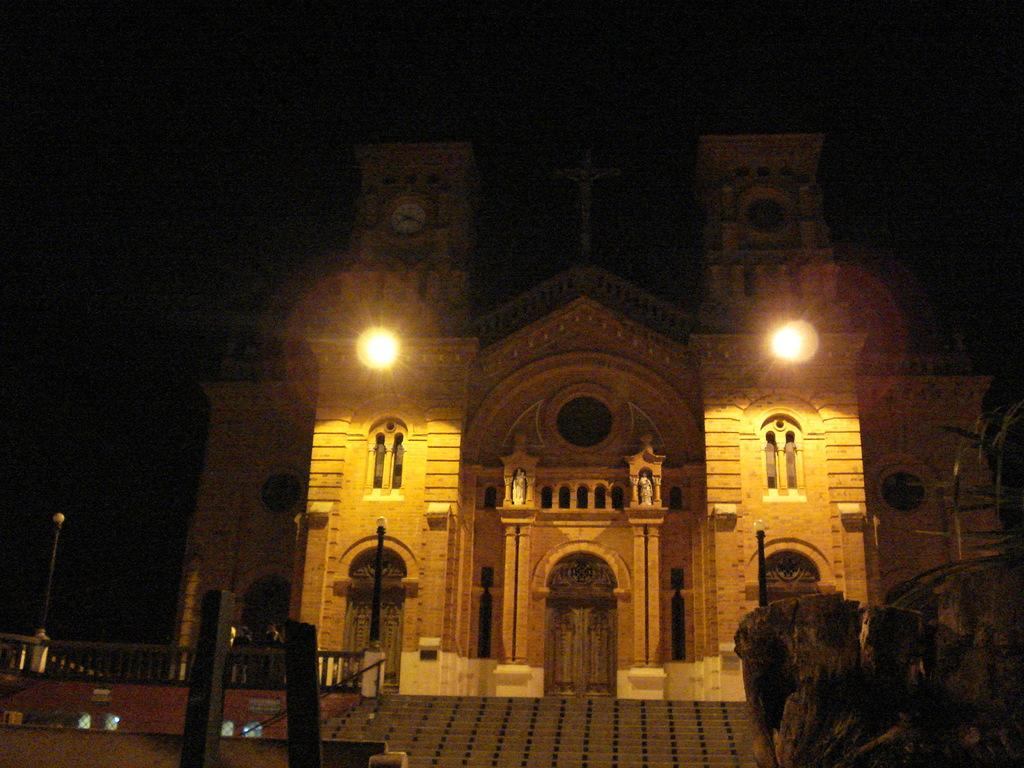What type of structure is visible in the image? There is a building in the image. What can be seen illuminating the area in the image? There are lights in the image. What are the vertical structures in the image used for? There are poles in the image, which are likely used for supporting the lights or other infrastructure. How can someone access different levels of the building in the image? There are stairs in the image, which provide a means of accessing different levels. Where is the toothbrush located in the image? There is no toothbrush present in the image. What type of detail can be seen on the building's facade in the image? The provided facts do not mention any specific details on the building's facade, so we cannot answer this question definitively. 